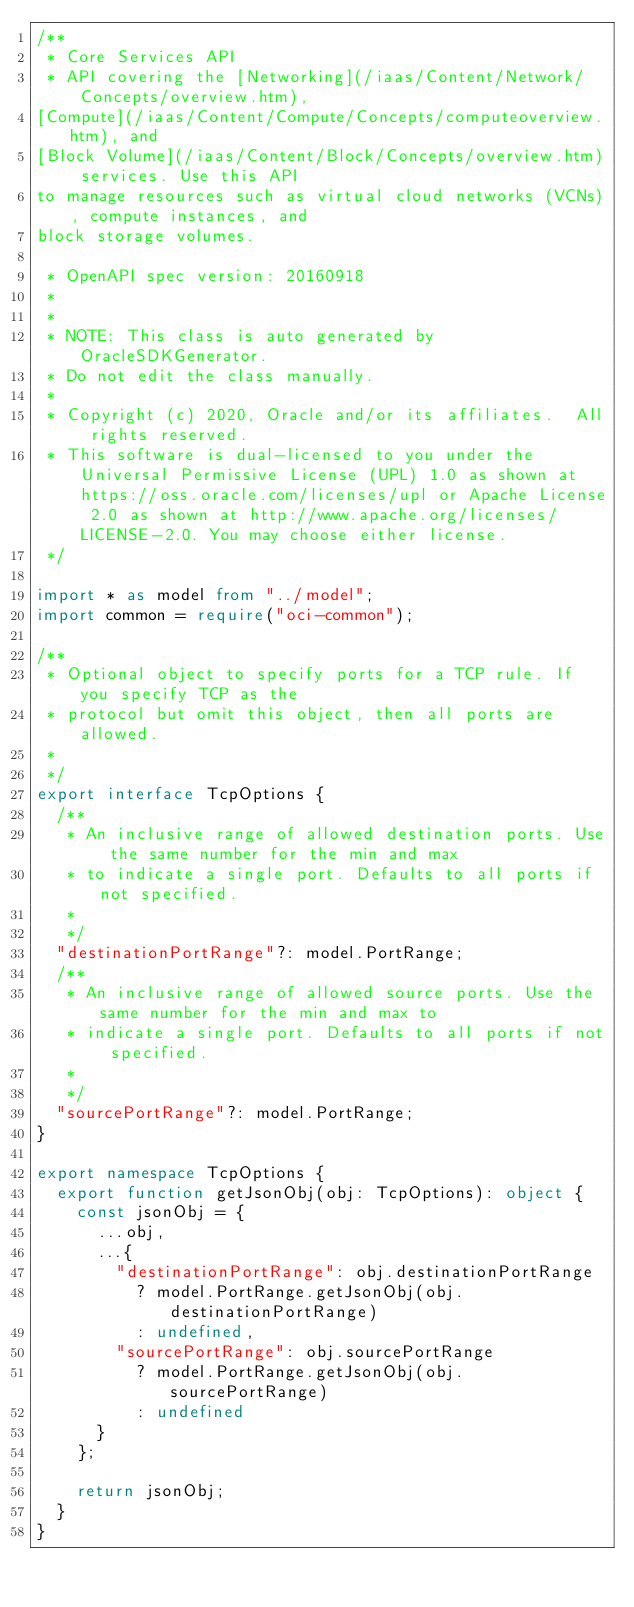Convert code to text. <code><loc_0><loc_0><loc_500><loc_500><_TypeScript_>/**
 * Core Services API
 * API covering the [Networking](/iaas/Content/Network/Concepts/overview.htm),
[Compute](/iaas/Content/Compute/Concepts/computeoverview.htm), and
[Block Volume](/iaas/Content/Block/Concepts/overview.htm) services. Use this API
to manage resources such as virtual cloud networks (VCNs), compute instances, and
block storage volumes.

 * OpenAPI spec version: 20160918
 * 
 *
 * NOTE: This class is auto generated by OracleSDKGenerator.
 * Do not edit the class manually.
 *
 * Copyright (c) 2020, Oracle and/or its affiliates.  All rights reserved.
 * This software is dual-licensed to you under the Universal Permissive License (UPL) 1.0 as shown at https://oss.oracle.com/licenses/upl or Apache License 2.0 as shown at http://www.apache.org/licenses/LICENSE-2.0. You may choose either license.
 */

import * as model from "../model";
import common = require("oci-common");

/**
 * Optional object to specify ports for a TCP rule. If you specify TCP as the
 * protocol but omit this object, then all ports are allowed.
 *
 */
export interface TcpOptions {
  /**
   * An inclusive range of allowed destination ports. Use the same number for the min and max
   * to indicate a single port. Defaults to all ports if not specified.
   *
   */
  "destinationPortRange"?: model.PortRange;
  /**
   * An inclusive range of allowed source ports. Use the same number for the min and max to
   * indicate a single port. Defaults to all ports if not specified.
   *
   */
  "sourcePortRange"?: model.PortRange;
}

export namespace TcpOptions {
  export function getJsonObj(obj: TcpOptions): object {
    const jsonObj = {
      ...obj,
      ...{
        "destinationPortRange": obj.destinationPortRange
          ? model.PortRange.getJsonObj(obj.destinationPortRange)
          : undefined,
        "sourcePortRange": obj.sourcePortRange
          ? model.PortRange.getJsonObj(obj.sourcePortRange)
          : undefined
      }
    };

    return jsonObj;
  }
}
</code> 